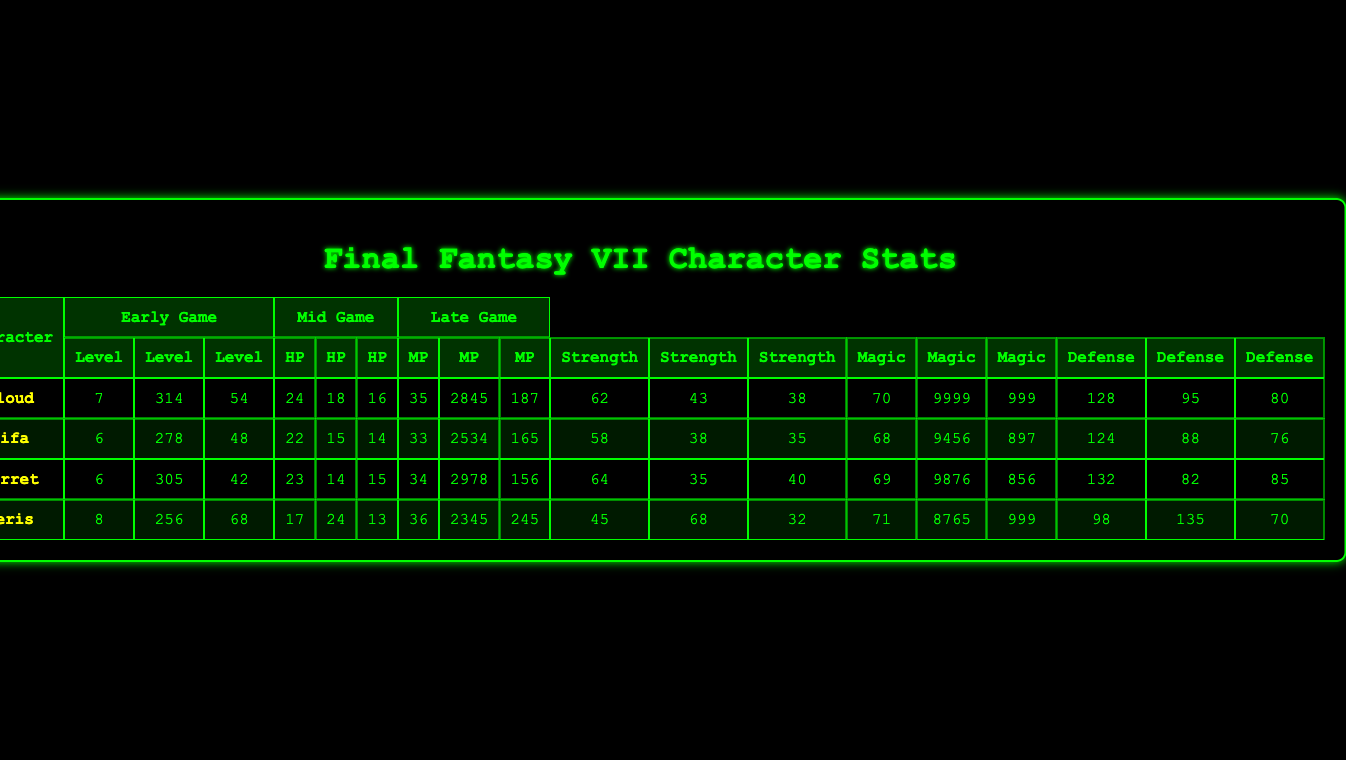What is Cloud's HP in the Late Game? Cloud's HP in the Late Game is given in the table under the Late Game column for the HP stat. It shows a value of 9999.
Answer: 9999 What is Tifa's Level in the Mid Game? Tifa's Level in the Mid Game can be found in the Mid Game column for the Level stat. The table indicates this value is 33.
Answer: 33 Which character has the highest Defense in the Early Game? To find this, we compare the Defense values of all characters in the Early Game. The values are: Cloud (16), Tifa (14), Barret (15), Aeris (13). Cloud has the highest Defense with a value of 16.
Answer: Cloud What is the average Strength of all characters in the Late Game? First, we need to find the Strength values for all characters in the Late Game: Cloud (128), Tifa (124), Barret (132), Aeris (98). Then, we sum them: 128 + 124 + 132 + 98 = 482. Dividing by 4 gives us an average of 120.5.
Answer: 120.5 Does Barret have more HP in the Mid Game than Tifa? Looking at the table, Barret's HP in the Mid Game is 2978, while Tifa's is 2534. Since 2978 is greater than 2534, the answer is yes.
Answer: Yes What is the difference in MP between Aeris in Early Game and Cloud in Early Game? For Aeris in Early Game, the MP is 68, and for Cloud in Early Game, it is 54. The difference is calculated as 68 - 54 = 14.
Answer: 14 Which character gained the most HP from Early to Late Game? We calculate the HP increase for each character: Cloud (9999 - 314 = 9685), Tifa (9456 - 278 = 9178), Barret (9876 - 305 = 9571), and Aeris (8765 - 256 = 8509). Cloud gained the most HP with an increase of 9685.
Answer: Cloud What is the total MP of all characters in Mid Game? The MP values for Mid Game are: Cloud (187), Tifa (165), Barret (156), Aeris (245). Summing them gives 187 + 165 + 156 + 245 = 753.
Answer: 753 Is it true that Tifa has a higher Strength than Cloud in the Mid Game? From the table, Tifa's Strength in Mid Game is 58, while Cloud's is 62. Since 58 is less than 62, the statement is false.
Answer: No What is the highest Magic stat among all characters in Late Game? The Magic stats in Late Game are: Cloud (95), Tifa (88), Barret (82), Aeris (135). The highest value is from Aeris with a Magic stat of 135.
Answer: Aeris 